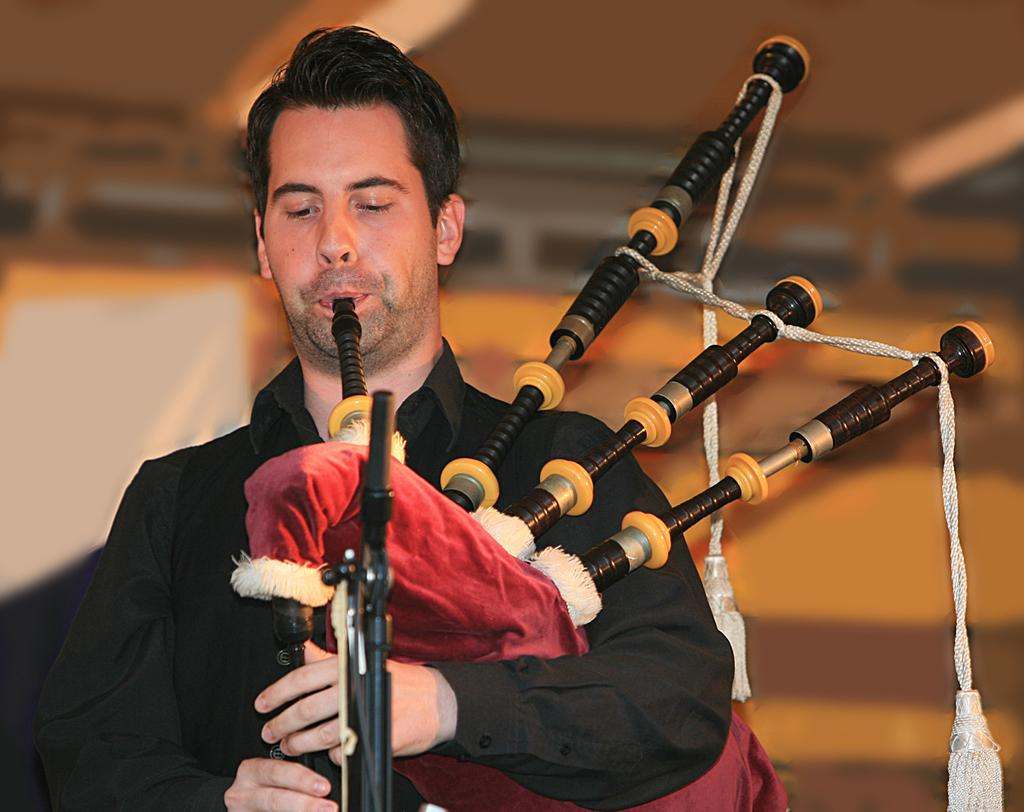What is the person in the image doing? The person is playing bagpipes. What is in front of the person? There is a stand in front of the person. Can you describe the background of the image? The background of the image is blurred. What type of zephyr can be seen interacting with the bagpipes in the image? There is no zephyr present in the image, and therefore no such interaction can be observed. 